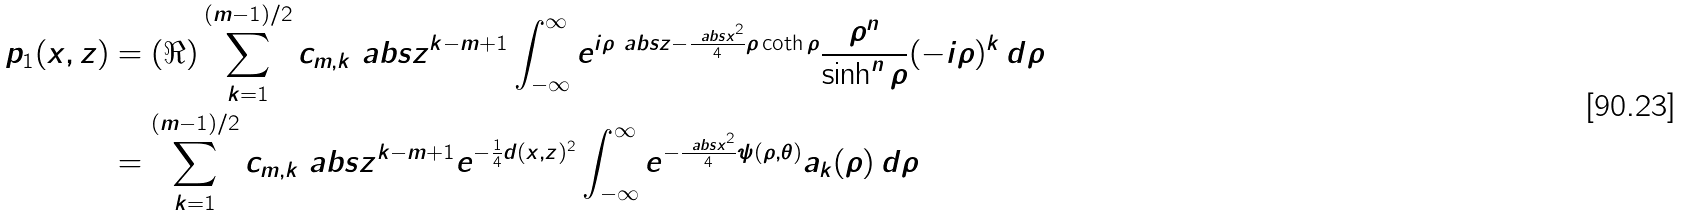Convert formula to latex. <formula><loc_0><loc_0><loc_500><loc_500>p _ { 1 } ( x , z ) & = ( \Re ) \sum _ { k = 1 } ^ { ( m - 1 ) / 2 } c _ { m , k } \ a b s { z } ^ { k - m + 1 } \int _ { - \infty } ^ { \infty } e ^ { { i } \rho \ a b s { z } - \frac { \ a b s { x } ^ { 2 } } { 4 } \rho \coth \rho } \frac { \rho ^ { n } } { \sinh ^ { n } \rho } ( - i \rho ) ^ { k } \, d \rho \\ & = \sum _ { k = 1 } ^ { ( m - 1 ) / 2 } c _ { m , k } \ a b s { z } ^ { k - m + 1 } e ^ { - \frac { 1 } { 4 } d ( x , z ) ^ { 2 } } \int _ { - \infty } ^ { \infty } e ^ { - \frac { \ a b s { x } ^ { 2 } } { 4 } \psi ( \rho , \theta ) } a _ { k } ( \rho ) \, d \rho</formula> 